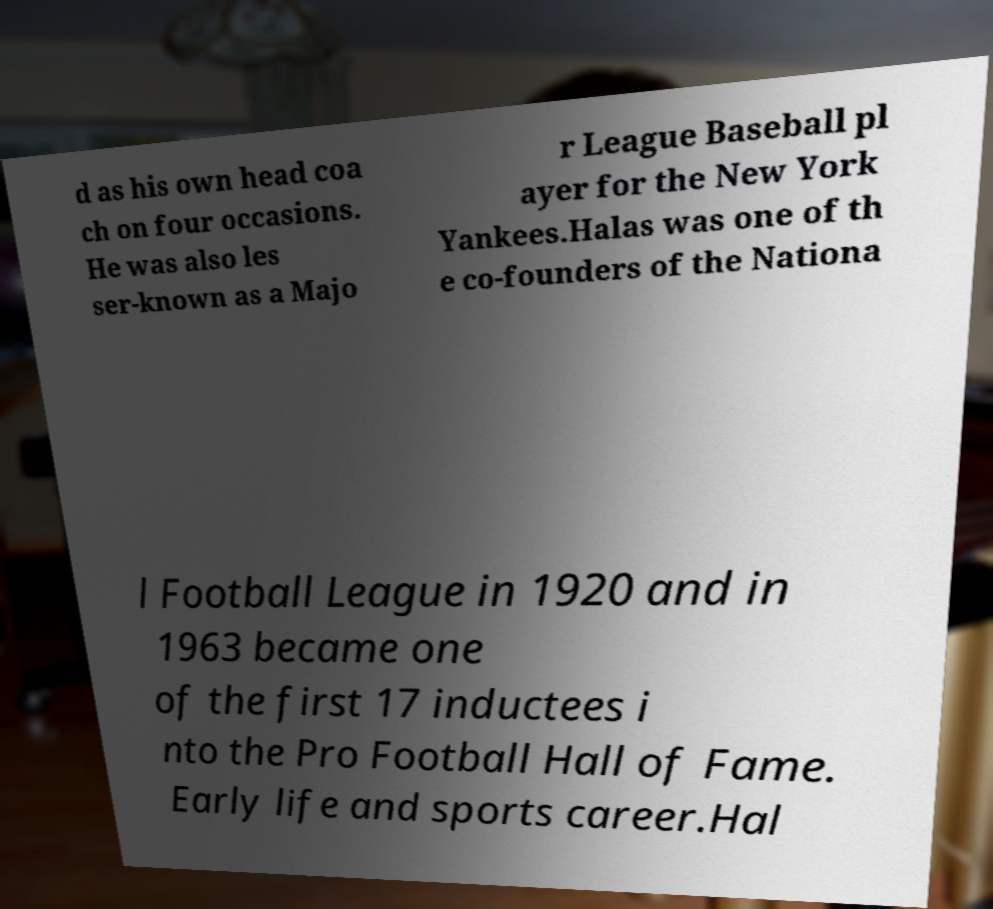What messages or text are displayed in this image? I need them in a readable, typed format. d as his own head coa ch on four occasions. He was also les ser-known as a Majo r League Baseball pl ayer for the New York Yankees.Halas was one of th e co-founders of the Nationa l Football League in 1920 and in 1963 became one of the first 17 inductees i nto the Pro Football Hall of Fame. Early life and sports career.Hal 